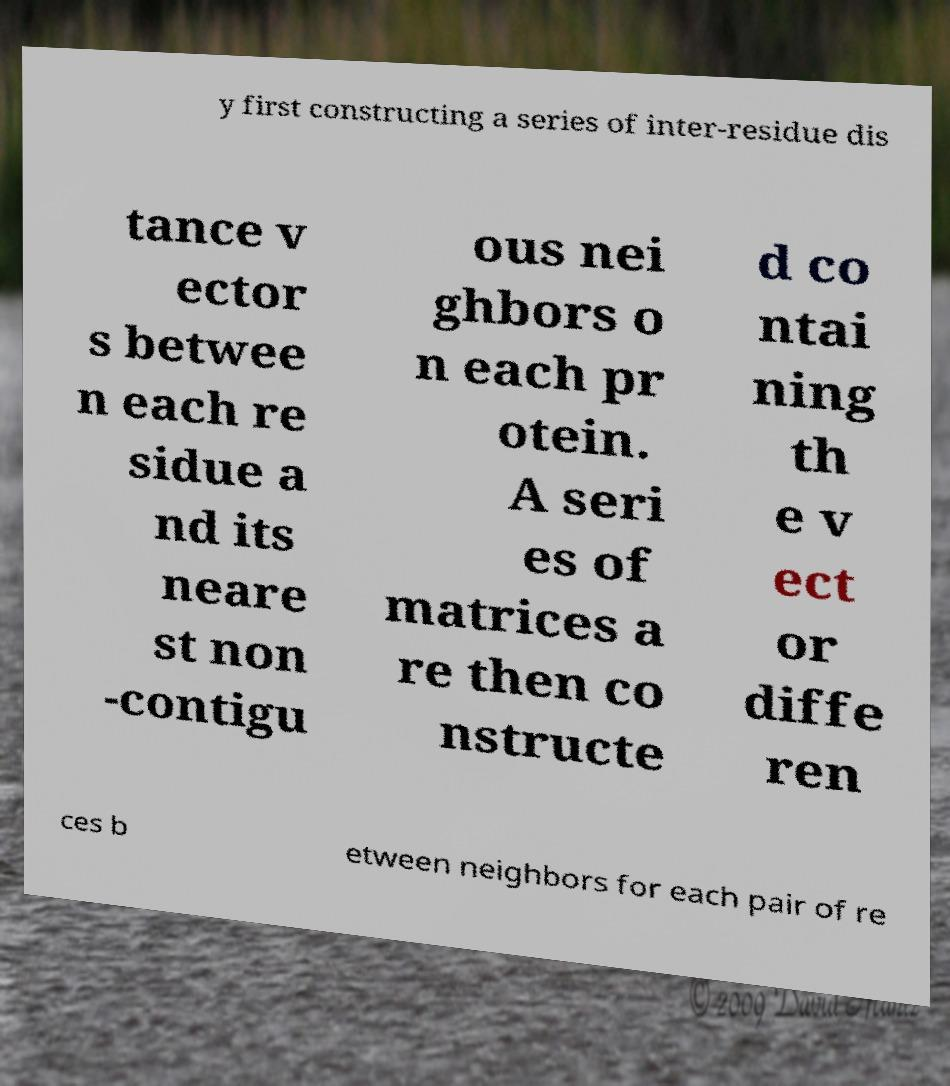Could you extract and type out the text from this image? y first constructing a series of inter-residue dis tance v ector s betwee n each re sidue a nd its neare st non -contigu ous nei ghbors o n each pr otein. A seri es of matrices a re then co nstructe d co ntai ning th e v ect or diffe ren ces b etween neighbors for each pair of re 